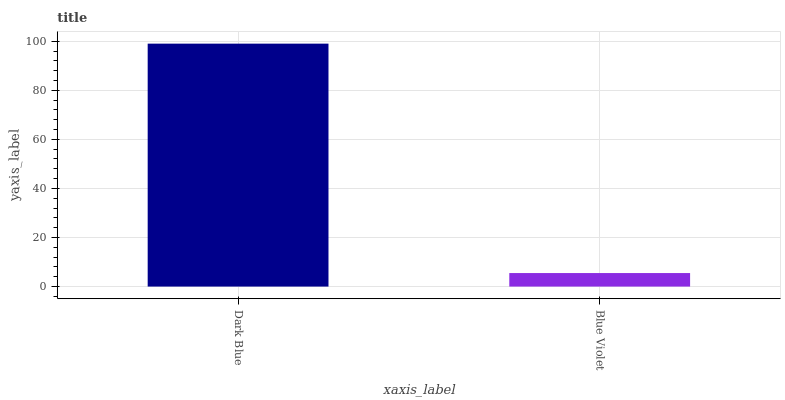Is Blue Violet the minimum?
Answer yes or no. Yes. Is Dark Blue the maximum?
Answer yes or no. Yes. Is Blue Violet the maximum?
Answer yes or no. No. Is Dark Blue greater than Blue Violet?
Answer yes or no. Yes. Is Blue Violet less than Dark Blue?
Answer yes or no. Yes. Is Blue Violet greater than Dark Blue?
Answer yes or no. No. Is Dark Blue less than Blue Violet?
Answer yes or no. No. Is Dark Blue the high median?
Answer yes or no. Yes. Is Blue Violet the low median?
Answer yes or no. Yes. Is Blue Violet the high median?
Answer yes or no. No. Is Dark Blue the low median?
Answer yes or no. No. 